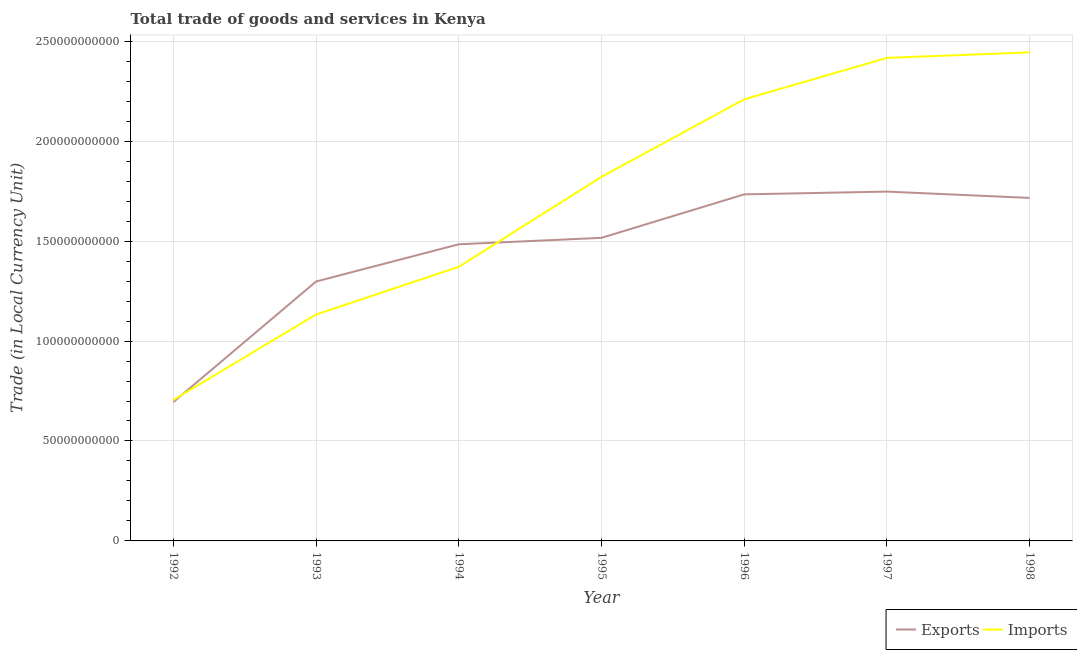Does the line corresponding to export of goods and services intersect with the line corresponding to imports of goods and services?
Offer a terse response. Yes. What is the imports of goods and services in 1994?
Your answer should be very brief. 1.37e+11. Across all years, what is the maximum imports of goods and services?
Offer a very short reply. 2.44e+11. Across all years, what is the minimum imports of goods and services?
Give a very brief answer. 7.05e+1. In which year was the export of goods and services maximum?
Keep it short and to the point. 1997. What is the total imports of goods and services in the graph?
Your response must be concise. 1.21e+12. What is the difference between the export of goods and services in 1992 and that in 1996?
Keep it short and to the point. -1.04e+11. What is the difference between the imports of goods and services in 1997 and the export of goods and services in 1995?
Provide a succinct answer. 9.00e+1. What is the average export of goods and services per year?
Your answer should be very brief. 1.46e+11. In the year 1992, what is the difference between the imports of goods and services and export of goods and services?
Offer a terse response. 1.08e+09. In how many years, is the imports of goods and services greater than 230000000000 LCU?
Your answer should be very brief. 2. What is the ratio of the export of goods and services in 1992 to that in 1995?
Provide a short and direct response. 0.46. What is the difference between the highest and the second highest export of goods and services?
Provide a short and direct response. 1.38e+09. What is the difference between the highest and the lowest export of goods and services?
Offer a terse response. 1.05e+11. In how many years, is the imports of goods and services greater than the average imports of goods and services taken over all years?
Keep it short and to the point. 4. Is the imports of goods and services strictly less than the export of goods and services over the years?
Provide a succinct answer. No. How many lines are there?
Offer a terse response. 2. What is the difference between two consecutive major ticks on the Y-axis?
Ensure brevity in your answer.  5.00e+1. Are the values on the major ticks of Y-axis written in scientific E-notation?
Make the answer very short. No. Does the graph contain any zero values?
Your response must be concise. No. Where does the legend appear in the graph?
Your response must be concise. Bottom right. What is the title of the graph?
Give a very brief answer. Total trade of goods and services in Kenya. What is the label or title of the Y-axis?
Keep it short and to the point. Trade (in Local Currency Unit). What is the Trade (in Local Currency Unit) in Exports in 1992?
Ensure brevity in your answer.  6.95e+1. What is the Trade (in Local Currency Unit) in Imports in 1992?
Give a very brief answer. 7.05e+1. What is the Trade (in Local Currency Unit) of Exports in 1993?
Your answer should be compact. 1.30e+11. What is the Trade (in Local Currency Unit) in Imports in 1993?
Provide a short and direct response. 1.13e+11. What is the Trade (in Local Currency Unit) of Exports in 1994?
Give a very brief answer. 1.48e+11. What is the Trade (in Local Currency Unit) of Imports in 1994?
Give a very brief answer. 1.37e+11. What is the Trade (in Local Currency Unit) in Exports in 1995?
Offer a terse response. 1.52e+11. What is the Trade (in Local Currency Unit) of Imports in 1995?
Provide a short and direct response. 1.82e+11. What is the Trade (in Local Currency Unit) of Exports in 1996?
Make the answer very short. 1.73e+11. What is the Trade (in Local Currency Unit) in Imports in 1996?
Provide a short and direct response. 2.21e+11. What is the Trade (in Local Currency Unit) of Exports in 1997?
Offer a very short reply. 1.75e+11. What is the Trade (in Local Currency Unit) of Imports in 1997?
Keep it short and to the point. 2.42e+11. What is the Trade (in Local Currency Unit) of Exports in 1998?
Provide a short and direct response. 1.72e+11. What is the Trade (in Local Currency Unit) in Imports in 1998?
Offer a terse response. 2.44e+11. Across all years, what is the maximum Trade (in Local Currency Unit) of Exports?
Offer a terse response. 1.75e+11. Across all years, what is the maximum Trade (in Local Currency Unit) of Imports?
Ensure brevity in your answer.  2.44e+11. Across all years, what is the minimum Trade (in Local Currency Unit) of Exports?
Provide a succinct answer. 6.95e+1. Across all years, what is the minimum Trade (in Local Currency Unit) of Imports?
Offer a terse response. 7.05e+1. What is the total Trade (in Local Currency Unit) in Exports in the graph?
Keep it short and to the point. 1.02e+12. What is the total Trade (in Local Currency Unit) in Imports in the graph?
Provide a short and direct response. 1.21e+12. What is the difference between the Trade (in Local Currency Unit) of Exports in 1992 and that in 1993?
Make the answer very short. -6.03e+1. What is the difference between the Trade (in Local Currency Unit) of Imports in 1992 and that in 1993?
Your response must be concise. -4.27e+1. What is the difference between the Trade (in Local Currency Unit) of Exports in 1992 and that in 1994?
Keep it short and to the point. -7.90e+1. What is the difference between the Trade (in Local Currency Unit) of Imports in 1992 and that in 1994?
Make the answer very short. -6.66e+1. What is the difference between the Trade (in Local Currency Unit) in Exports in 1992 and that in 1995?
Your answer should be very brief. -8.22e+1. What is the difference between the Trade (in Local Currency Unit) in Imports in 1992 and that in 1995?
Give a very brief answer. -1.12e+11. What is the difference between the Trade (in Local Currency Unit) of Exports in 1992 and that in 1996?
Give a very brief answer. -1.04e+11. What is the difference between the Trade (in Local Currency Unit) of Imports in 1992 and that in 1996?
Ensure brevity in your answer.  -1.50e+11. What is the difference between the Trade (in Local Currency Unit) of Exports in 1992 and that in 1997?
Offer a very short reply. -1.05e+11. What is the difference between the Trade (in Local Currency Unit) of Imports in 1992 and that in 1997?
Make the answer very short. -1.71e+11. What is the difference between the Trade (in Local Currency Unit) of Exports in 1992 and that in 1998?
Your answer should be very brief. -1.02e+11. What is the difference between the Trade (in Local Currency Unit) in Imports in 1992 and that in 1998?
Provide a short and direct response. -1.74e+11. What is the difference between the Trade (in Local Currency Unit) of Exports in 1993 and that in 1994?
Make the answer very short. -1.86e+1. What is the difference between the Trade (in Local Currency Unit) of Imports in 1993 and that in 1994?
Your response must be concise. -2.39e+1. What is the difference between the Trade (in Local Currency Unit) of Exports in 1993 and that in 1995?
Make the answer very short. -2.18e+1. What is the difference between the Trade (in Local Currency Unit) of Imports in 1993 and that in 1995?
Offer a very short reply. -6.89e+1. What is the difference between the Trade (in Local Currency Unit) in Exports in 1993 and that in 1996?
Your answer should be compact. -4.36e+1. What is the difference between the Trade (in Local Currency Unit) of Imports in 1993 and that in 1996?
Offer a very short reply. -1.08e+11. What is the difference between the Trade (in Local Currency Unit) in Exports in 1993 and that in 1997?
Give a very brief answer. -4.50e+1. What is the difference between the Trade (in Local Currency Unit) of Imports in 1993 and that in 1997?
Offer a terse response. -1.28e+11. What is the difference between the Trade (in Local Currency Unit) of Exports in 1993 and that in 1998?
Give a very brief answer. -4.18e+1. What is the difference between the Trade (in Local Currency Unit) of Imports in 1993 and that in 1998?
Keep it short and to the point. -1.31e+11. What is the difference between the Trade (in Local Currency Unit) in Exports in 1994 and that in 1995?
Make the answer very short. -3.23e+09. What is the difference between the Trade (in Local Currency Unit) in Imports in 1994 and that in 1995?
Offer a very short reply. -4.50e+1. What is the difference between the Trade (in Local Currency Unit) in Exports in 1994 and that in 1996?
Provide a short and direct response. -2.50e+1. What is the difference between the Trade (in Local Currency Unit) in Imports in 1994 and that in 1996?
Offer a terse response. -8.38e+1. What is the difference between the Trade (in Local Currency Unit) of Exports in 1994 and that in 1997?
Make the answer very short. -2.64e+1. What is the difference between the Trade (in Local Currency Unit) in Imports in 1994 and that in 1997?
Keep it short and to the point. -1.05e+11. What is the difference between the Trade (in Local Currency Unit) of Exports in 1994 and that in 1998?
Your answer should be very brief. -2.32e+1. What is the difference between the Trade (in Local Currency Unit) of Imports in 1994 and that in 1998?
Keep it short and to the point. -1.07e+11. What is the difference between the Trade (in Local Currency Unit) in Exports in 1995 and that in 1996?
Make the answer very short. -2.17e+1. What is the difference between the Trade (in Local Currency Unit) of Imports in 1995 and that in 1996?
Ensure brevity in your answer.  -3.88e+1. What is the difference between the Trade (in Local Currency Unit) of Exports in 1995 and that in 1997?
Your answer should be very brief. -2.31e+1. What is the difference between the Trade (in Local Currency Unit) in Imports in 1995 and that in 1997?
Your answer should be very brief. -5.95e+1. What is the difference between the Trade (in Local Currency Unit) in Exports in 1995 and that in 1998?
Your answer should be compact. -2.00e+1. What is the difference between the Trade (in Local Currency Unit) in Imports in 1995 and that in 1998?
Offer a very short reply. -6.23e+1. What is the difference between the Trade (in Local Currency Unit) of Exports in 1996 and that in 1997?
Offer a very short reply. -1.38e+09. What is the difference between the Trade (in Local Currency Unit) of Imports in 1996 and that in 1997?
Your answer should be compact. -2.07e+1. What is the difference between the Trade (in Local Currency Unit) of Exports in 1996 and that in 1998?
Your answer should be compact. 1.78e+09. What is the difference between the Trade (in Local Currency Unit) of Imports in 1996 and that in 1998?
Your answer should be very brief. -2.35e+1. What is the difference between the Trade (in Local Currency Unit) in Exports in 1997 and that in 1998?
Your answer should be very brief. 3.15e+09. What is the difference between the Trade (in Local Currency Unit) in Imports in 1997 and that in 1998?
Your answer should be compact. -2.77e+09. What is the difference between the Trade (in Local Currency Unit) of Exports in 1992 and the Trade (in Local Currency Unit) of Imports in 1993?
Offer a terse response. -4.38e+1. What is the difference between the Trade (in Local Currency Unit) in Exports in 1992 and the Trade (in Local Currency Unit) in Imports in 1994?
Ensure brevity in your answer.  -6.77e+1. What is the difference between the Trade (in Local Currency Unit) in Exports in 1992 and the Trade (in Local Currency Unit) in Imports in 1995?
Your answer should be very brief. -1.13e+11. What is the difference between the Trade (in Local Currency Unit) of Exports in 1992 and the Trade (in Local Currency Unit) of Imports in 1996?
Your answer should be very brief. -1.51e+11. What is the difference between the Trade (in Local Currency Unit) in Exports in 1992 and the Trade (in Local Currency Unit) in Imports in 1997?
Make the answer very short. -1.72e+11. What is the difference between the Trade (in Local Currency Unit) in Exports in 1992 and the Trade (in Local Currency Unit) in Imports in 1998?
Ensure brevity in your answer.  -1.75e+11. What is the difference between the Trade (in Local Currency Unit) in Exports in 1993 and the Trade (in Local Currency Unit) in Imports in 1994?
Give a very brief answer. -7.34e+09. What is the difference between the Trade (in Local Currency Unit) in Exports in 1993 and the Trade (in Local Currency Unit) in Imports in 1995?
Offer a terse response. -5.24e+1. What is the difference between the Trade (in Local Currency Unit) in Exports in 1993 and the Trade (in Local Currency Unit) in Imports in 1996?
Your response must be concise. -9.11e+1. What is the difference between the Trade (in Local Currency Unit) of Exports in 1993 and the Trade (in Local Currency Unit) of Imports in 1997?
Provide a short and direct response. -1.12e+11. What is the difference between the Trade (in Local Currency Unit) in Exports in 1993 and the Trade (in Local Currency Unit) in Imports in 1998?
Keep it short and to the point. -1.15e+11. What is the difference between the Trade (in Local Currency Unit) of Exports in 1994 and the Trade (in Local Currency Unit) of Imports in 1995?
Ensure brevity in your answer.  -3.38e+1. What is the difference between the Trade (in Local Currency Unit) in Exports in 1994 and the Trade (in Local Currency Unit) in Imports in 1996?
Offer a very short reply. -7.25e+1. What is the difference between the Trade (in Local Currency Unit) in Exports in 1994 and the Trade (in Local Currency Unit) in Imports in 1997?
Offer a terse response. -9.32e+1. What is the difference between the Trade (in Local Currency Unit) of Exports in 1994 and the Trade (in Local Currency Unit) of Imports in 1998?
Your answer should be very brief. -9.60e+1. What is the difference between the Trade (in Local Currency Unit) of Exports in 1995 and the Trade (in Local Currency Unit) of Imports in 1996?
Offer a terse response. -6.93e+1. What is the difference between the Trade (in Local Currency Unit) in Exports in 1995 and the Trade (in Local Currency Unit) in Imports in 1997?
Make the answer very short. -9.00e+1. What is the difference between the Trade (in Local Currency Unit) in Exports in 1995 and the Trade (in Local Currency Unit) in Imports in 1998?
Your response must be concise. -9.28e+1. What is the difference between the Trade (in Local Currency Unit) in Exports in 1996 and the Trade (in Local Currency Unit) in Imports in 1997?
Your answer should be very brief. -6.83e+1. What is the difference between the Trade (in Local Currency Unit) in Exports in 1996 and the Trade (in Local Currency Unit) in Imports in 1998?
Give a very brief answer. -7.10e+1. What is the difference between the Trade (in Local Currency Unit) of Exports in 1997 and the Trade (in Local Currency Unit) of Imports in 1998?
Provide a short and direct response. -6.97e+1. What is the average Trade (in Local Currency Unit) of Exports per year?
Offer a very short reply. 1.46e+11. What is the average Trade (in Local Currency Unit) in Imports per year?
Keep it short and to the point. 1.73e+11. In the year 1992, what is the difference between the Trade (in Local Currency Unit) in Exports and Trade (in Local Currency Unit) in Imports?
Provide a short and direct response. -1.08e+09. In the year 1993, what is the difference between the Trade (in Local Currency Unit) in Exports and Trade (in Local Currency Unit) in Imports?
Make the answer very short. 1.65e+1. In the year 1994, what is the difference between the Trade (in Local Currency Unit) of Exports and Trade (in Local Currency Unit) of Imports?
Your answer should be compact. 1.13e+1. In the year 1995, what is the difference between the Trade (in Local Currency Unit) of Exports and Trade (in Local Currency Unit) of Imports?
Your answer should be very brief. -3.05e+1. In the year 1996, what is the difference between the Trade (in Local Currency Unit) of Exports and Trade (in Local Currency Unit) of Imports?
Your response must be concise. -4.75e+1. In the year 1997, what is the difference between the Trade (in Local Currency Unit) in Exports and Trade (in Local Currency Unit) in Imports?
Keep it short and to the point. -6.69e+1. In the year 1998, what is the difference between the Trade (in Local Currency Unit) in Exports and Trade (in Local Currency Unit) in Imports?
Provide a succinct answer. -7.28e+1. What is the ratio of the Trade (in Local Currency Unit) of Exports in 1992 to that in 1993?
Your response must be concise. 0.54. What is the ratio of the Trade (in Local Currency Unit) in Imports in 1992 to that in 1993?
Provide a succinct answer. 0.62. What is the ratio of the Trade (in Local Currency Unit) of Exports in 1992 to that in 1994?
Give a very brief answer. 0.47. What is the ratio of the Trade (in Local Currency Unit) in Imports in 1992 to that in 1994?
Offer a very short reply. 0.51. What is the ratio of the Trade (in Local Currency Unit) of Exports in 1992 to that in 1995?
Make the answer very short. 0.46. What is the ratio of the Trade (in Local Currency Unit) of Imports in 1992 to that in 1995?
Your response must be concise. 0.39. What is the ratio of the Trade (in Local Currency Unit) of Exports in 1992 to that in 1996?
Make the answer very short. 0.4. What is the ratio of the Trade (in Local Currency Unit) of Imports in 1992 to that in 1996?
Your answer should be compact. 0.32. What is the ratio of the Trade (in Local Currency Unit) in Exports in 1992 to that in 1997?
Your answer should be very brief. 0.4. What is the ratio of the Trade (in Local Currency Unit) in Imports in 1992 to that in 1997?
Give a very brief answer. 0.29. What is the ratio of the Trade (in Local Currency Unit) in Exports in 1992 to that in 1998?
Make the answer very short. 0.4. What is the ratio of the Trade (in Local Currency Unit) of Imports in 1992 to that in 1998?
Keep it short and to the point. 0.29. What is the ratio of the Trade (in Local Currency Unit) in Exports in 1993 to that in 1994?
Provide a succinct answer. 0.87. What is the ratio of the Trade (in Local Currency Unit) in Imports in 1993 to that in 1994?
Offer a terse response. 0.83. What is the ratio of the Trade (in Local Currency Unit) in Exports in 1993 to that in 1995?
Offer a terse response. 0.86. What is the ratio of the Trade (in Local Currency Unit) in Imports in 1993 to that in 1995?
Ensure brevity in your answer.  0.62. What is the ratio of the Trade (in Local Currency Unit) of Exports in 1993 to that in 1996?
Provide a short and direct response. 0.75. What is the ratio of the Trade (in Local Currency Unit) in Imports in 1993 to that in 1996?
Make the answer very short. 0.51. What is the ratio of the Trade (in Local Currency Unit) in Exports in 1993 to that in 1997?
Offer a very short reply. 0.74. What is the ratio of the Trade (in Local Currency Unit) of Imports in 1993 to that in 1997?
Provide a short and direct response. 0.47. What is the ratio of the Trade (in Local Currency Unit) of Exports in 1993 to that in 1998?
Your answer should be compact. 0.76. What is the ratio of the Trade (in Local Currency Unit) in Imports in 1993 to that in 1998?
Provide a short and direct response. 0.46. What is the ratio of the Trade (in Local Currency Unit) of Exports in 1994 to that in 1995?
Keep it short and to the point. 0.98. What is the ratio of the Trade (in Local Currency Unit) of Imports in 1994 to that in 1995?
Your answer should be very brief. 0.75. What is the ratio of the Trade (in Local Currency Unit) of Exports in 1994 to that in 1996?
Your response must be concise. 0.86. What is the ratio of the Trade (in Local Currency Unit) of Imports in 1994 to that in 1996?
Ensure brevity in your answer.  0.62. What is the ratio of the Trade (in Local Currency Unit) of Exports in 1994 to that in 1997?
Offer a terse response. 0.85. What is the ratio of the Trade (in Local Currency Unit) in Imports in 1994 to that in 1997?
Provide a short and direct response. 0.57. What is the ratio of the Trade (in Local Currency Unit) in Exports in 1994 to that in 1998?
Provide a succinct answer. 0.86. What is the ratio of the Trade (in Local Currency Unit) in Imports in 1994 to that in 1998?
Your response must be concise. 0.56. What is the ratio of the Trade (in Local Currency Unit) in Exports in 1995 to that in 1996?
Offer a terse response. 0.87. What is the ratio of the Trade (in Local Currency Unit) in Imports in 1995 to that in 1996?
Your response must be concise. 0.82. What is the ratio of the Trade (in Local Currency Unit) of Exports in 1995 to that in 1997?
Provide a short and direct response. 0.87. What is the ratio of the Trade (in Local Currency Unit) in Imports in 1995 to that in 1997?
Offer a very short reply. 0.75. What is the ratio of the Trade (in Local Currency Unit) of Exports in 1995 to that in 1998?
Provide a short and direct response. 0.88. What is the ratio of the Trade (in Local Currency Unit) of Imports in 1995 to that in 1998?
Provide a short and direct response. 0.75. What is the ratio of the Trade (in Local Currency Unit) of Imports in 1996 to that in 1997?
Make the answer very short. 0.91. What is the ratio of the Trade (in Local Currency Unit) of Exports in 1996 to that in 1998?
Offer a terse response. 1.01. What is the ratio of the Trade (in Local Currency Unit) in Imports in 1996 to that in 1998?
Ensure brevity in your answer.  0.9. What is the ratio of the Trade (in Local Currency Unit) in Exports in 1997 to that in 1998?
Your answer should be compact. 1.02. What is the ratio of the Trade (in Local Currency Unit) of Imports in 1997 to that in 1998?
Offer a terse response. 0.99. What is the difference between the highest and the second highest Trade (in Local Currency Unit) of Exports?
Offer a very short reply. 1.38e+09. What is the difference between the highest and the second highest Trade (in Local Currency Unit) of Imports?
Make the answer very short. 2.77e+09. What is the difference between the highest and the lowest Trade (in Local Currency Unit) of Exports?
Your answer should be compact. 1.05e+11. What is the difference between the highest and the lowest Trade (in Local Currency Unit) in Imports?
Provide a succinct answer. 1.74e+11. 